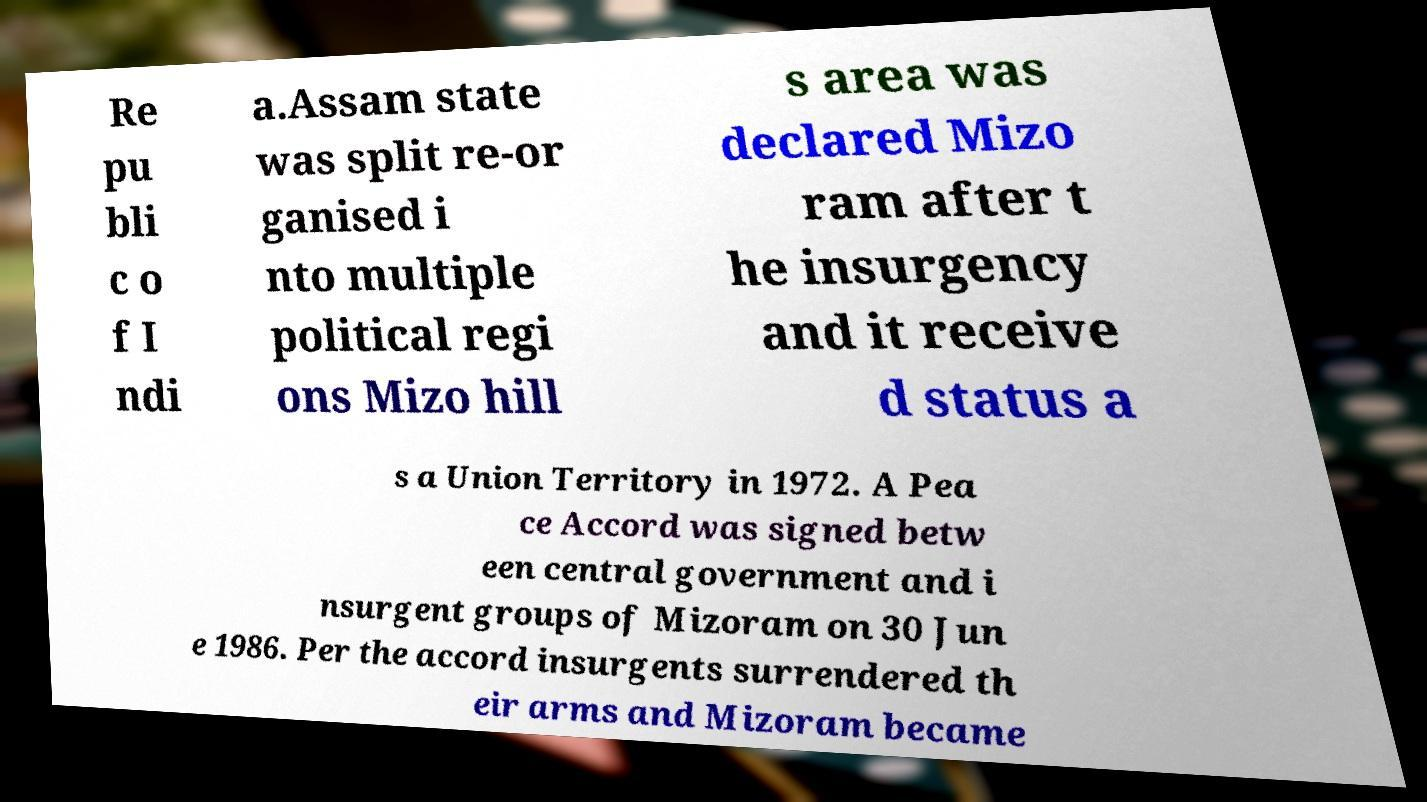Could you assist in decoding the text presented in this image and type it out clearly? Re pu bli c o f I ndi a.Assam state was split re-or ganised i nto multiple political regi ons Mizo hill s area was declared Mizo ram after t he insurgency and it receive d status a s a Union Territory in 1972. A Pea ce Accord was signed betw een central government and i nsurgent groups of Mizoram on 30 Jun e 1986. Per the accord insurgents surrendered th eir arms and Mizoram became 